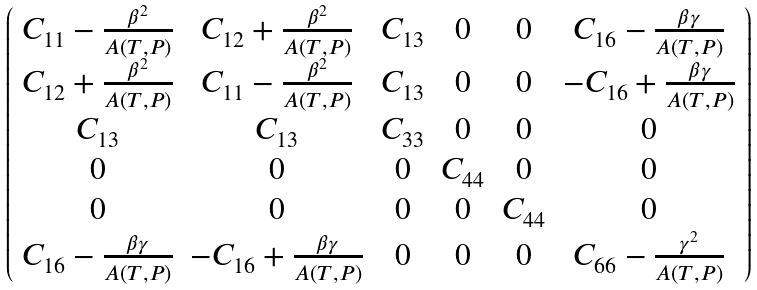<formula> <loc_0><loc_0><loc_500><loc_500>\left ( \begin{array} { c c c c c c } C _ { 1 1 } - \frac { \beta ^ { 2 } } { A ( T , P ) } & C _ { 1 2 } + \frac { \beta ^ { 2 } } { A ( T , P ) } & C _ { 1 3 } & 0 & 0 & C _ { 1 6 } - \frac { \beta \gamma } { A ( T , P ) } \\ C _ { 1 2 } + \frac { \beta ^ { 2 } } { A ( T , P ) } & C _ { 1 1 } - \frac { \beta ^ { 2 } } { A ( T , P ) } & C _ { 1 3 } & 0 & 0 & - C _ { 1 6 } + \frac { \beta \gamma } { A ( T , P ) } \\ C _ { 1 3 } & C _ { 1 3 } & C _ { 3 3 } & 0 & 0 & 0 \\ 0 & 0 & 0 & C _ { 4 4 } & 0 & 0 \\ 0 & 0 & 0 & 0 & C _ { 4 4 } & 0 \\ C _ { 1 6 } - \frac { \beta \gamma } { A ( T , P ) } & - C _ { 1 6 } + \frac { \beta \gamma } { A ( T , P ) } & 0 & 0 & 0 & C _ { 6 6 } - \frac { \gamma ^ { 2 } } { A ( T , P ) } \\ \end{array} \right )</formula> 